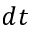Convert formula to latex. <formula><loc_0><loc_0><loc_500><loc_500>d t</formula> 